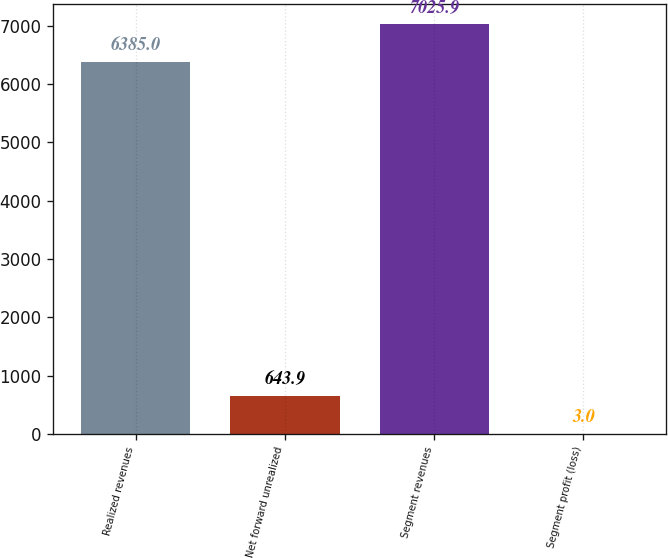Convert chart. <chart><loc_0><loc_0><loc_500><loc_500><bar_chart><fcel>Realized revenues<fcel>Net forward unrealized<fcel>Segment revenues<fcel>Segment profit (loss)<nl><fcel>6385<fcel>643.9<fcel>7025.9<fcel>3<nl></chart> 